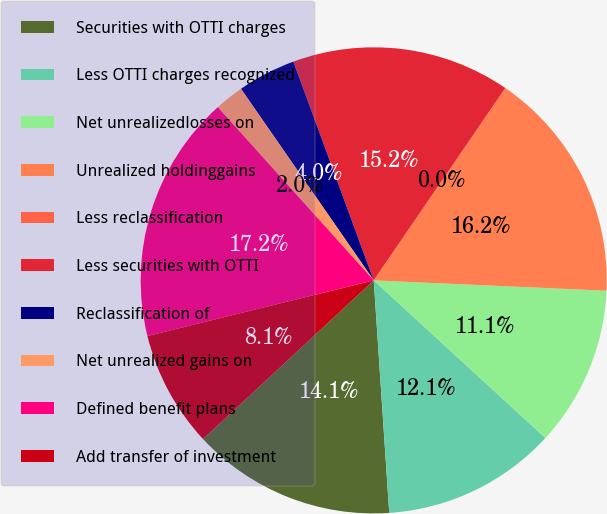Convert chart. <chart><loc_0><loc_0><loc_500><loc_500><pie_chart><fcel>Securities with OTTI charges<fcel>Less OTTI charges recognized<fcel>Net unrealizedlosses on<fcel>Unrealized holdinggains<fcel>Less reclassification<fcel>Less securities with OTTI<fcel>Reclassification of<fcel>Net unrealized gains on<fcel>Defined benefit plans<fcel>Add transfer of investment<nl><fcel>14.14%<fcel>12.12%<fcel>11.11%<fcel>16.16%<fcel>0.0%<fcel>15.15%<fcel>4.04%<fcel>2.02%<fcel>17.17%<fcel>8.08%<nl></chart> 